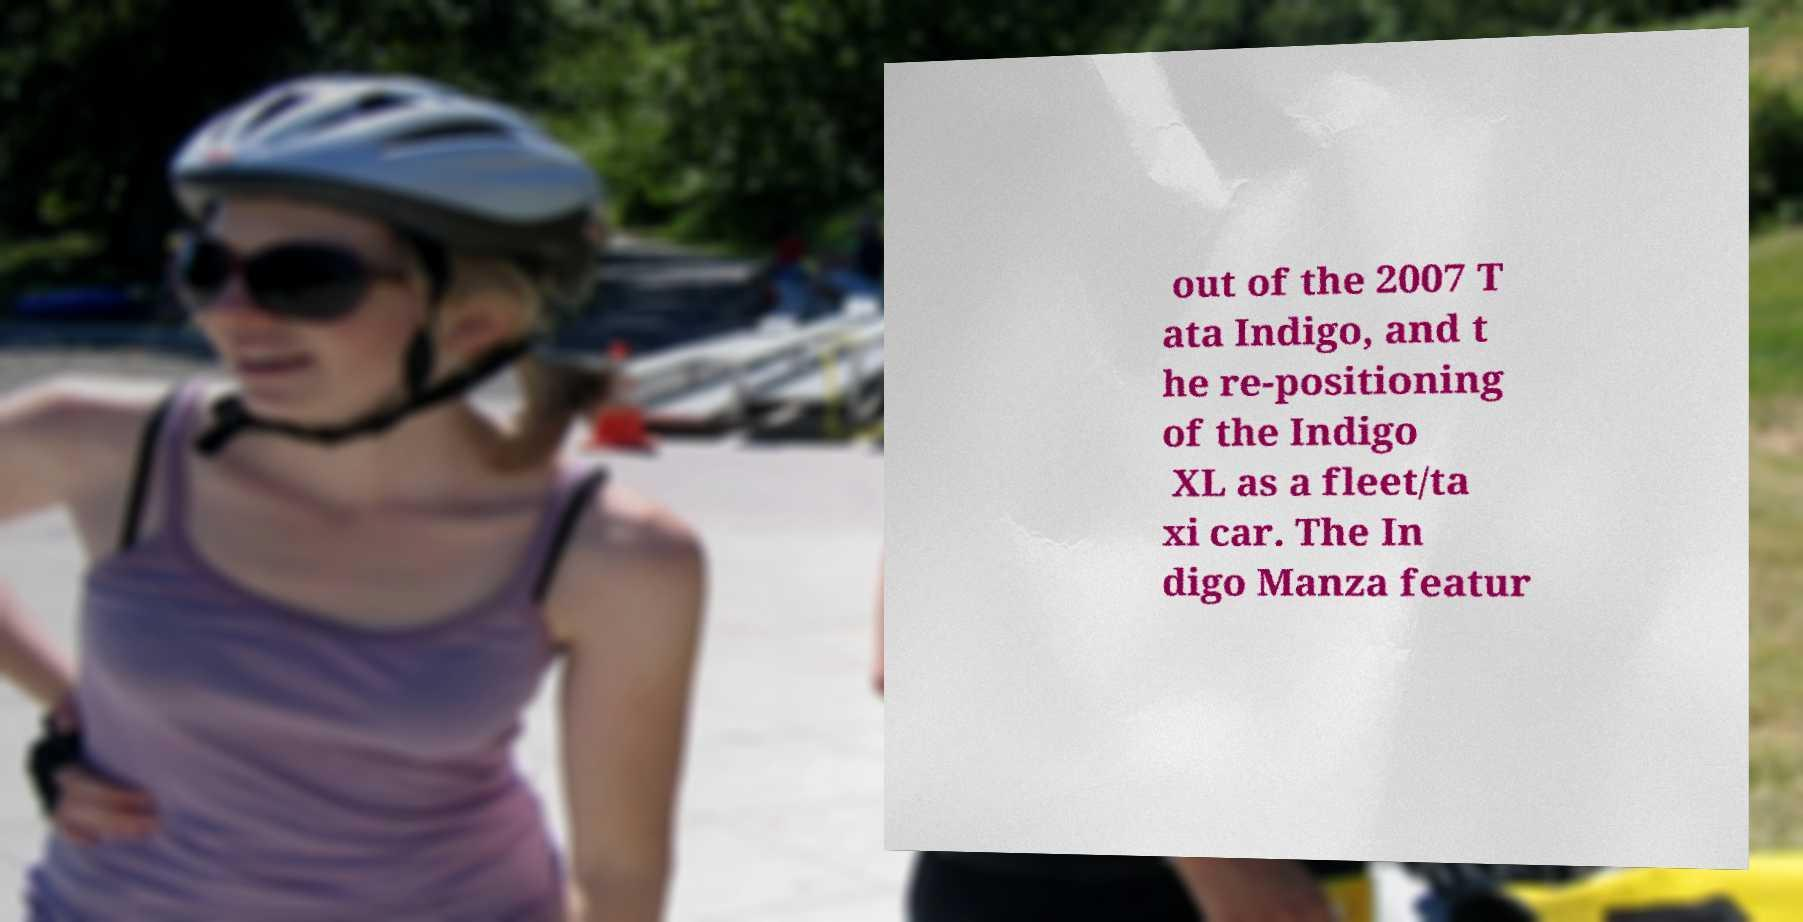Can you read and provide the text displayed in the image?This photo seems to have some interesting text. Can you extract and type it out for me? out of the 2007 T ata Indigo, and t he re-positioning of the Indigo XL as a fleet/ta xi car. The In digo Manza featur 